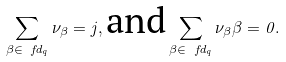<formula> <loc_0><loc_0><loc_500><loc_500>\sum _ { \beta \in \ f d _ { q } } \nu _ { \beta } = j , \text {and} \sum _ { \beta \in \ f d _ { q } } \nu _ { \beta } \beta = 0 .</formula> 